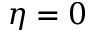Convert formula to latex. <formula><loc_0><loc_0><loc_500><loc_500>\eta = 0</formula> 